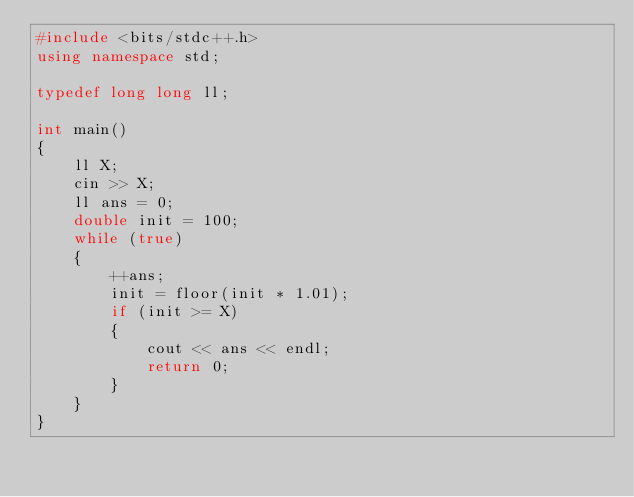Convert code to text. <code><loc_0><loc_0><loc_500><loc_500><_C++_>#include <bits/stdc++.h>
using namespace std;

typedef long long ll;

int main()
{
    ll X;
    cin >> X;
    ll ans = 0;
    double init = 100;
    while (true)
    {
        ++ans;
        init = floor(init * 1.01);
        if (init >= X)
        {
            cout << ans << endl;
            return 0;
        }
    }
}
</code> 